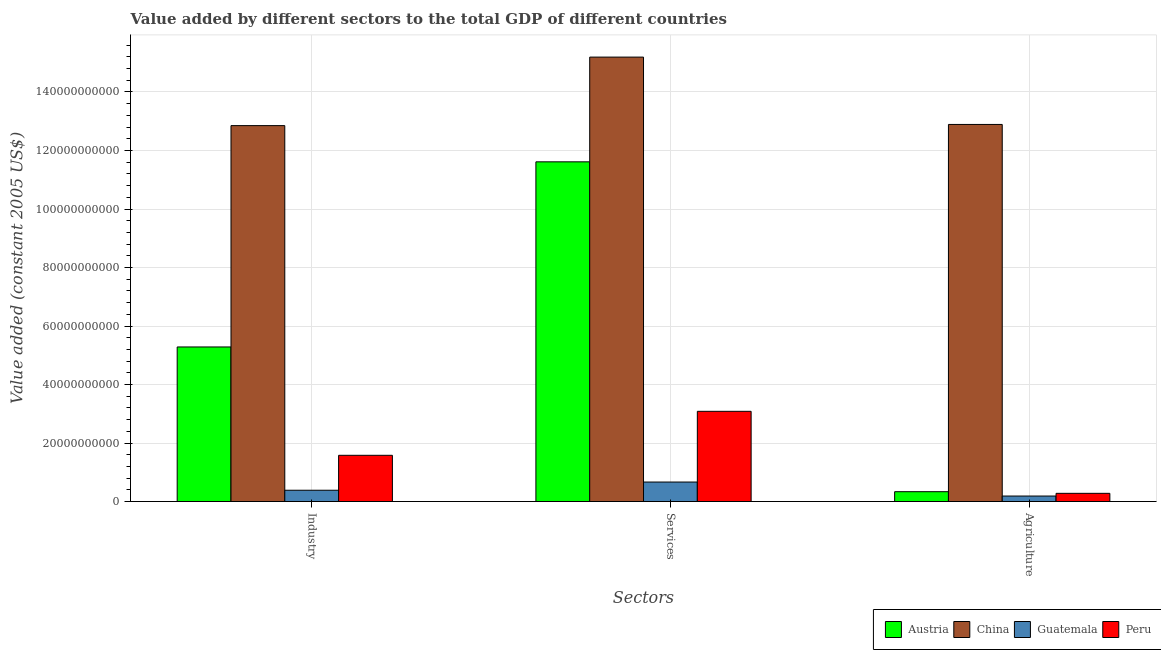How many different coloured bars are there?
Ensure brevity in your answer.  4. How many groups of bars are there?
Provide a succinct answer. 3. How many bars are there on the 1st tick from the left?
Make the answer very short. 4. What is the label of the 3rd group of bars from the left?
Provide a short and direct response. Agriculture. What is the value added by agricultural sector in Guatemala?
Offer a terse response. 1.89e+09. Across all countries, what is the maximum value added by agricultural sector?
Offer a terse response. 1.29e+11. Across all countries, what is the minimum value added by agricultural sector?
Provide a succinct answer. 1.89e+09. In which country was the value added by industrial sector minimum?
Your answer should be compact. Guatemala. What is the total value added by services in the graph?
Your answer should be compact. 3.06e+11. What is the difference between the value added by services in Austria and that in Peru?
Your answer should be compact. 8.53e+1. What is the difference between the value added by industrial sector in Austria and the value added by agricultural sector in Peru?
Provide a short and direct response. 5.00e+1. What is the average value added by services per country?
Your answer should be very brief. 7.64e+1. What is the difference between the value added by industrial sector and value added by services in China?
Ensure brevity in your answer.  -2.34e+1. In how many countries, is the value added by industrial sector greater than 104000000000 US$?
Offer a terse response. 1. What is the ratio of the value added by agricultural sector in Peru to that in China?
Offer a very short reply. 0.02. Is the value added by services in Peru less than that in China?
Keep it short and to the point. Yes. Is the difference between the value added by agricultural sector in Guatemala and Peru greater than the difference between the value added by services in Guatemala and Peru?
Make the answer very short. Yes. What is the difference between the highest and the second highest value added by industrial sector?
Your response must be concise. 7.57e+1. What is the difference between the highest and the lowest value added by services?
Your response must be concise. 1.45e+11. Is the sum of the value added by agricultural sector in China and Austria greater than the maximum value added by services across all countries?
Provide a short and direct response. No. What does the 3rd bar from the right in Industry represents?
Provide a succinct answer. China. Is it the case that in every country, the sum of the value added by industrial sector and value added by services is greater than the value added by agricultural sector?
Provide a short and direct response. Yes. Are all the bars in the graph horizontal?
Your response must be concise. No. How many countries are there in the graph?
Keep it short and to the point. 4. Does the graph contain any zero values?
Give a very brief answer. No. Does the graph contain grids?
Offer a terse response. Yes. Where does the legend appear in the graph?
Ensure brevity in your answer.  Bottom right. What is the title of the graph?
Ensure brevity in your answer.  Value added by different sectors to the total GDP of different countries. Does "Macedonia" appear as one of the legend labels in the graph?
Make the answer very short. No. What is the label or title of the X-axis?
Provide a short and direct response. Sectors. What is the label or title of the Y-axis?
Your response must be concise. Value added (constant 2005 US$). What is the Value added (constant 2005 US$) of Austria in Industry?
Provide a succinct answer. 5.28e+1. What is the Value added (constant 2005 US$) of China in Industry?
Your answer should be compact. 1.29e+11. What is the Value added (constant 2005 US$) in Guatemala in Industry?
Offer a terse response. 3.87e+09. What is the Value added (constant 2005 US$) in Peru in Industry?
Provide a succinct answer. 1.58e+1. What is the Value added (constant 2005 US$) of Austria in Services?
Ensure brevity in your answer.  1.16e+11. What is the Value added (constant 2005 US$) of China in Services?
Your response must be concise. 1.52e+11. What is the Value added (constant 2005 US$) of Guatemala in Services?
Provide a succinct answer. 6.68e+09. What is the Value added (constant 2005 US$) of Peru in Services?
Make the answer very short. 3.08e+1. What is the Value added (constant 2005 US$) in Austria in Agriculture?
Provide a succinct answer. 3.37e+09. What is the Value added (constant 2005 US$) in China in Agriculture?
Your response must be concise. 1.29e+11. What is the Value added (constant 2005 US$) of Guatemala in Agriculture?
Make the answer very short. 1.89e+09. What is the Value added (constant 2005 US$) of Peru in Agriculture?
Make the answer very short. 2.81e+09. Across all Sectors, what is the maximum Value added (constant 2005 US$) of Austria?
Your response must be concise. 1.16e+11. Across all Sectors, what is the maximum Value added (constant 2005 US$) of China?
Give a very brief answer. 1.52e+11. Across all Sectors, what is the maximum Value added (constant 2005 US$) of Guatemala?
Keep it short and to the point. 6.68e+09. Across all Sectors, what is the maximum Value added (constant 2005 US$) of Peru?
Your answer should be compact. 3.08e+1. Across all Sectors, what is the minimum Value added (constant 2005 US$) of Austria?
Offer a terse response. 3.37e+09. Across all Sectors, what is the minimum Value added (constant 2005 US$) in China?
Provide a succinct answer. 1.29e+11. Across all Sectors, what is the minimum Value added (constant 2005 US$) of Guatemala?
Offer a very short reply. 1.89e+09. Across all Sectors, what is the minimum Value added (constant 2005 US$) in Peru?
Your answer should be compact. 2.81e+09. What is the total Value added (constant 2005 US$) in Austria in the graph?
Keep it short and to the point. 1.72e+11. What is the total Value added (constant 2005 US$) of China in the graph?
Make the answer very short. 4.09e+11. What is the total Value added (constant 2005 US$) of Guatemala in the graph?
Make the answer very short. 1.24e+1. What is the total Value added (constant 2005 US$) of Peru in the graph?
Keep it short and to the point. 4.95e+1. What is the difference between the Value added (constant 2005 US$) of Austria in Industry and that in Services?
Provide a succinct answer. -6.33e+1. What is the difference between the Value added (constant 2005 US$) of China in Industry and that in Services?
Offer a very short reply. -2.34e+1. What is the difference between the Value added (constant 2005 US$) in Guatemala in Industry and that in Services?
Your answer should be compact. -2.80e+09. What is the difference between the Value added (constant 2005 US$) in Peru in Industry and that in Services?
Provide a succinct answer. -1.50e+1. What is the difference between the Value added (constant 2005 US$) in Austria in Industry and that in Agriculture?
Make the answer very short. 4.95e+1. What is the difference between the Value added (constant 2005 US$) of China in Industry and that in Agriculture?
Your answer should be very brief. -3.98e+08. What is the difference between the Value added (constant 2005 US$) in Guatemala in Industry and that in Agriculture?
Provide a succinct answer. 1.98e+09. What is the difference between the Value added (constant 2005 US$) in Peru in Industry and that in Agriculture?
Your answer should be compact. 1.30e+1. What is the difference between the Value added (constant 2005 US$) of Austria in Services and that in Agriculture?
Ensure brevity in your answer.  1.13e+11. What is the difference between the Value added (constant 2005 US$) in China in Services and that in Agriculture?
Your answer should be compact. 2.30e+1. What is the difference between the Value added (constant 2005 US$) in Guatemala in Services and that in Agriculture?
Your answer should be very brief. 4.79e+09. What is the difference between the Value added (constant 2005 US$) of Peru in Services and that in Agriculture?
Offer a terse response. 2.80e+1. What is the difference between the Value added (constant 2005 US$) in Austria in Industry and the Value added (constant 2005 US$) in China in Services?
Make the answer very short. -9.91e+1. What is the difference between the Value added (constant 2005 US$) of Austria in Industry and the Value added (constant 2005 US$) of Guatemala in Services?
Make the answer very short. 4.62e+1. What is the difference between the Value added (constant 2005 US$) in Austria in Industry and the Value added (constant 2005 US$) in Peru in Services?
Make the answer very short. 2.20e+1. What is the difference between the Value added (constant 2005 US$) of China in Industry and the Value added (constant 2005 US$) of Guatemala in Services?
Your answer should be compact. 1.22e+11. What is the difference between the Value added (constant 2005 US$) of China in Industry and the Value added (constant 2005 US$) of Peru in Services?
Ensure brevity in your answer.  9.77e+1. What is the difference between the Value added (constant 2005 US$) in Guatemala in Industry and the Value added (constant 2005 US$) in Peru in Services?
Make the answer very short. -2.70e+1. What is the difference between the Value added (constant 2005 US$) of Austria in Industry and the Value added (constant 2005 US$) of China in Agriculture?
Your answer should be compact. -7.61e+1. What is the difference between the Value added (constant 2005 US$) in Austria in Industry and the Value added (constant 2005 US$) in Guatemala in Agriculture?
Your answer should be compact. 5.10e+1. What is the difference between the Value added (constant 2005 US$) in Austria in Industry and the Value added (constant 2005 US$) in Peru in Agriculture?
Ensure brevity in your answer.  5.00e+1. What is the difference between the Value added (constant 2005 US$) in China in Industry and the Value added (constant 2005 US$) in Guatemala in Agriculture?
Offer a terse response. 1.27e+11. What is the difference between the Value added (constant 2005 US$) of China in Industry and the Value added (constant 2005 US$) of Peru in Agriculture?
Provide a short and direct response. 1.26e+11. What is the difference between the Value added (constant 2005 US$) in Guatemala in Industry and the Value added (constant 2005 US$) in Peru in Agriculture?
Offer a very short reply. 1.06e+09. What is the difference between the Value added (constant 2005 US$) in Austria in Services and the Value added (constant 2005 US$) in China in Agriculture?
Give a very brief answer. -1.28e+1. What is the difference between the Value added (constant 2005 US$) in Austria in Services and the Value added (constant 2005 US$) in Guatemala in Agriculture?
Give a very brief answer. 1.14e+11. What is the difference between the Value added (constant 2005 US$) in Austria in Services and the Value added (constant 2005 US$) in Peru in Agriculture?
Your answer should be compact. 1.13e+11. What is the difference between the Value added (constant 2005 US$) of China in Services and the Value added (constant 2005 US$) of Guatemala in Agriculture?
Ensure brevity in your answer.  1.50e+11. What is the difference between the Value added (constant 2005 US$) in China in Services and the Value added (constant 2005 US$) in Peru in Agriculture?
Offer a very short reply. 1.49e+11. What is the difference between the Value added (constant 2005 US$) in Guatemala in Services and the Value added (constant 2005 US$) in Peru in Agriculture?
Provide a short and direct response. 3.86e+09. What is the average Value added (constant 2005 US$) in Austria per Sectors?
Offer a terse response. 5.74e+1. What is the average Value added (constant 2005 US$) in China per Sectors?
Ensure brevity in your answer.  1.36e+11. What is the average Value added (constant 2005 US$) in Guatemala per Sectors?
Provide a short and direct response. 4.14e+09. What is the average Value added (constant 2005 US$) of Peru per Sectors?
Your answer should be compact. 1.65e+1. What is the difference between the Value added (constant 2005 US$) of Austria and Value added (constant 2005 US$) of China in Industry?
Your answer should be compact. -7.57e+1. What is the difference between the Value added (constant 2005 US$) in Austria and Value added (constant 2005 US$) in Guatemala in Industry?
Give a very brief answer. 4.90e+1. What is the difference between the Value added (constant 2005 US$) in Austria and Value added (constant 2005 US$) in Peru in Industry?
Provide a succinct answer. 3.70e+1. What is the difference between the Value added (constant 2005 US$) of China and Value added (constant 2005 US$) of Guatemala in Industry?
Provide a short and direct response. 1.25e+11. What is the difference between the Value added (constant 2005 US$) in China and Value added (constant 2005 US$) in Peru in Industry?
Offer a very short reply. 1.13e+11. What is the difference between the Value added (constant 2005 US$) in Guatemala and Value added (constant 2005 US$) in Peru in Industry?
Ensure brevity in your answer.  -1.19e+1. What is the difference between the Value added (constant 2005 US$) of Austria and Value added (constant 2005 US$) of China in Services?
Your answer should be very brief. -3.58e+1. What is the difference between the Value added (constant 2005 US$) of Austria and Value added (constant 2005 US$) of Guatemala in Services?
Your answer should be compact. 1.09e+11. What is the difference between the Value added (constant 2005 US$) of Austria and Value added (constant 2005 US$) of Peru in Services?
Offer a very short reply. 8.53e+1. What is the difference between the Value added (constant 2005 US$) of China and Value added (constant 2005 US$) of Guatemala in Services?
Offer a terse response. 1.45e+11. What is the difference between the Value added (constant 2005 US$) of China and Value added (constant 2005 US$) of Peru in Services?
Give a very brief answer. 1.21e+11. What is the difference between the Value added (constant 2005 US$) of Guatemala and Value added (constant 2005 US$) of Peru in Services?
Your response must be concise. -2.42e+1. What is the difference between the Value added (constant 2005 US$) in Austria and Value added (constant 2005 US$) in China in Agriculture?
Your answer should be compact. -1.26e+11. What is the difference between the Value added (constant 2005 US$) in Austria and Value added (constant 2005 US$) in Guatemala in Agriculture?
Provide a succinct answer. 1.49e+09. What is the difference between the Value added (constant 2005 US$) of Austria and Value added (constant 2005 US$) of Peru in Agriculture?
Offer a very short reply. 5.61e+08. What is the difference between the Value added (constant 2005 US$) in China and Value added (constant 2005 US$) in Guatemala in Agriculture?
Your answer should be very brief. 1.27e+11. What is the difference between the Value added (constant 2005 US$) in China and Value added (constant 2005 US$) in Peru in Agriculture?
Give a very brief answer. 1.26e+11. What is the difference between the Value added (constant 2005 US$) in Guatemala and Value added (constant 2005 US$) in Peru in Agriculture?
Give a very brief answer. -9.26e+08. What is the ratio of the Value added (constant 2005 US$) of Austria in Industry to that in Services?
Make the answer very short. 0.46. What is the ratio of the Value added (constant 2005 US$) in China in Industry to that in Services?
Your answer should be compact. 0.85. What is the ratio of the Value added (constant 2005 US$) of Guatemala in Industry to that in Services?
Provide a short and direct response. 0.58. What is the ratio of the Value added (constant 2005 US$) in Peru in Industry to that in Services?
Offer a very short reply. 0.51. What is the ratio of the Value added (constant 2005 US$) in Austria in Industry to that in Agriculture?
Your answer should be compact. 15.66. What is the ratio of the Value added (constant 2005 US$) of Guatemala in Industry to that in Agriculture?
Give a very brief answer. 2.05. What is the ratio of the Value added (constant 2005 US$) in Peru in Industry to that in Agriculture?
Offer a terse response. 5.62. What is the ratio of the Value added (constant 2005 US$) in Austria in Services to that in Agriculture?
Your response must be concise. 34.41. What is the ratio of the Value added (constant 2005 US$) in China in Services to that in Agriculture?
Offer a very short reply. 1.18. What is the ratio of the Value added (constant 2005 US$) of Guatemala in Services to that in Agriculture?
Provide a short and direct response. 3.54. What is the ratio of the Value added (constant 2005 US$) of Peru in Services to that in Agriculture?
Give a very brief answer. 10.96. What is the difference between the highest and the second highest Value added (constant 2005 US$) of Austria?
Give a very brief answer. 6.33e+1. What is the difference between the highest and the second highest Value added (constant 2005 US$) of China?
Keep it short and to the point. 2.30e+1. What is the difference between the highest and the second highest Value added (constant 2005 US$) in Guatemala?
Your answer should be very brief. 2.80e+09. What is the difference between the highest and the second highest Value added (constant 2005 US$) of Peru?
Provide a short and direct response. 1.50e+1. What is the difference between the highest and the lowest Value added (constant 2005 US$) of Austria?
Your answer should be compact. 1.13e+11. What is the difference between the highest and the lowest Value added (constant 2005 US$) of China?
Offer a terse response. 2.34e+1. What is the difference between the highest and the lowest Value added (constant 2005 US$) of Guatemala?
Your answer should be very brief. 4.79e+09. What is the difference between the highest and the lowest Value added (constant 2005 US$) in Peru?
Provide a short and direct response. 2.80e+1. 